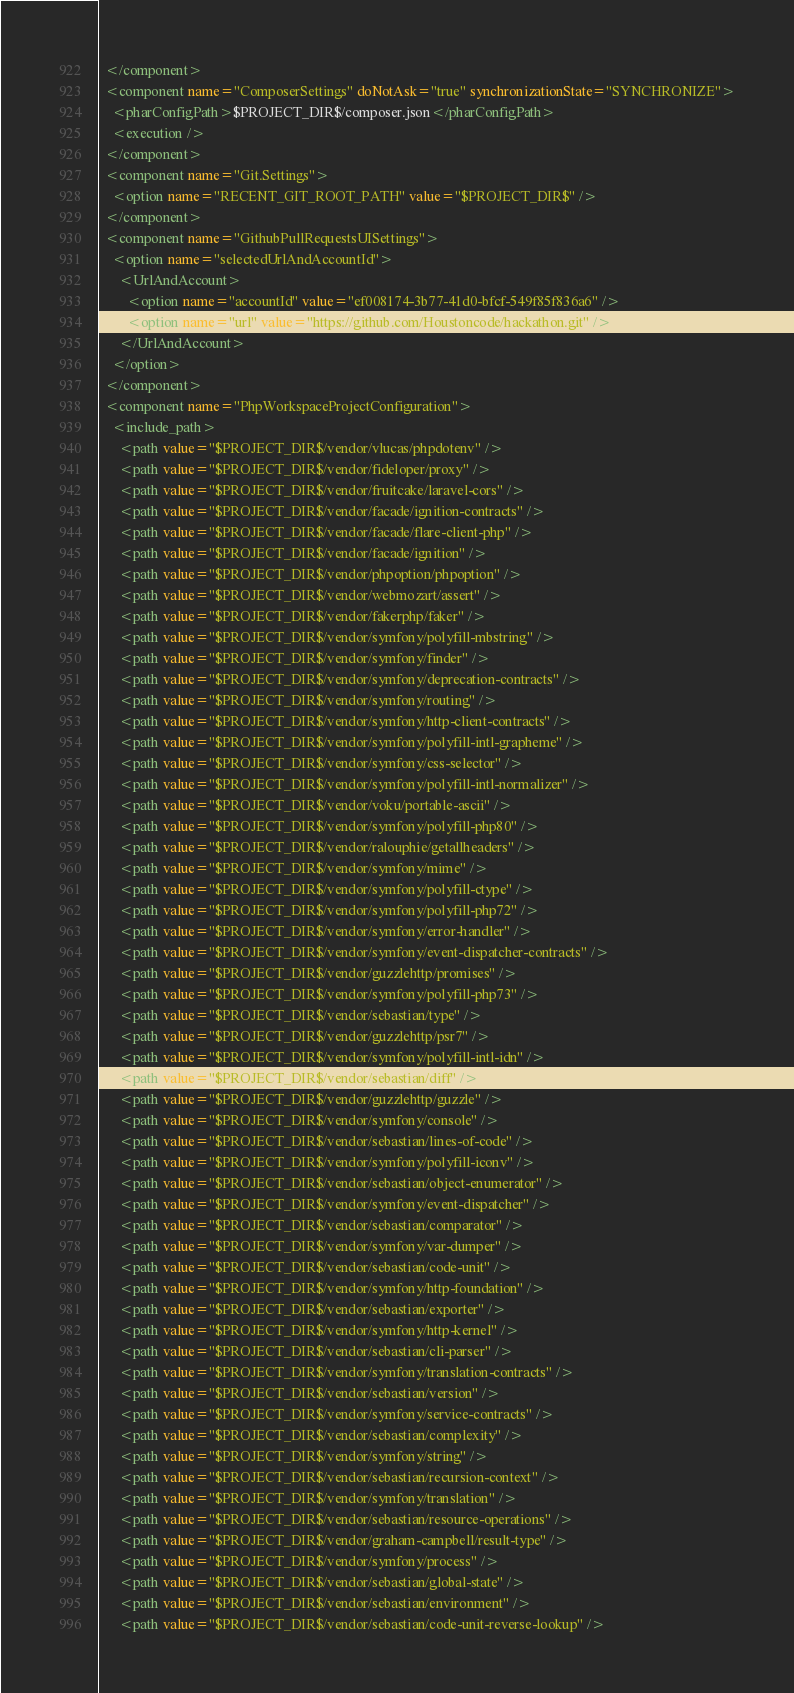Convert code to text. <code><loc_0><loc_0><loc_500><loc_500><_XML_>  </component>
  <component name="ComposerSettings" doNotAsk="true" synchronizationState="SYNCHRONIZE">
    <pharConfigPath>$PROJECT_DIR$/composer.json</pharConfigPath>
    <execution />
  </component>
  <component name="Git.Settings">
    <option name="RECENT_GIT_ROOT_PATH" value="$PROJECT_DIR$" />
  </component>
  <component name="GithubPullRequestsUISettings">
    <option name="selectedUrlAndAccountId">
      <UrlAndAccount>
        <option name="accountId" value="ef008174-3b77-41d0-bfcf-549f85f836a6" />
        <option name="url" value="https://github.com/Houstoncode/hackathon.git" />
      </UrlAndAccount>
    </option>
  </component>
  <component name="PhpWorkspaceProjectConfiguration">
    <include_path>
      <path value="$PROJECT_DIR$/vendor/vlucas/phpdotenv" />
      <path value="$PROJECT_DIR$/vendor/fideloper/proxy" />
      <path value="$PROJECT_DIR$/vendor/fruitcake/laravel-cors" />
      <path value="$PROJECT_DIR$/vendor/facade/ignition-contracts" />
      <path value="$PROJECT_DIR$/vendor/facade/flare-client-php" />
      <path value="$PROJECT_DIR$/vendor/facade/ignition" />
      <path value="$PROJECT_DIR$/vendor/phpoption/phpoption" />
      <path value="$PROJECT_DIR$/vendor/webmozart/assert" />
      <path value="$PROJECT_DIR$/vendor/fakerphp/faker" />
      <path value="$PROJECT_DIR$/vendor/symfony/polyfill-mbstring" />
      <path value="$PROJECT_DIR$/vendor/symfony/finder" />
      <path value="$PROJECT_DIR$/vendor/symfony/deprecation-contracts" />
      <path value="$PROJECT_DIR$/vendor/symfony/routing" />
      <path value="$PROJECT_DIR$/vendor/symfony/http-client-contracts" />
      <path value="$PROJECT_DIR$/vendor/symfony/polyfill-intl-grapheme" />
      <path value="$PROJECT_DIR$/vendor/symfony/css-selector" />
      <path value="$PROJECT_DIR$/vendor/symfony/polyfill-intl-normalizer" />
      <path value="$PROJECT_DIR$/vendor/voku/portable-ascii" />
      <path value="$PROJECT_DIR$/vendor/symfony/polyfill-php80" />
      <path value="$PROJECT_DIR$/vendor/ralouphie/getallheaders" />
      <path value="$PROJECT_DIR$/vendor/symfony/mime" />
      <path value="$PROJECT_DIR$/vendor/symfony/polyfill-ctype" />
      <path value="$PROJECT_DIR$/vendor/symfony/polyfill-php72" />
      <path value="$PROJECT_DIR$/vendor/symfony/error-handler" />
      <path value="$PROJECT_DIR$/vendor/symfony/event-dispatcher-contracts" />
      <path value="$PROJECT_DIR$/vendor/guzzlehttp/promises" />
      <path value="$PROJECT_DIR$/vendor/symfony/polyfill-php73" />
      <path value="$PROJECT_DIR$/vendor/sebastian/type" />
      <path value="$PROJECT_DIR$/vendor/guzzlehttp/psr7" />
      <path value="$PROJECT_DIR$/vendor/symfony/polyfill-intl-idn" />
      <path value="$PROJECT_DIR$/vendor/sebastian/diff" />
      <path value="$PROJECT_DIR$/vendor/guzzlehttp/guzzle" />
      <path value="$PROJECT_DIR$/vendor/symfony/console" />
      <path value="$PROJECT_DIR$/vendor/sebastian/lines-of-code" />
      <path value="$PROJECT_DIR$/vendor/symfony/polyfill-iconv" />
      <path value="$PROJECT_DIR$/vendor/sebastian/object-enumerator" />
      <path value="$PROJECT_DIR$/vendor/symfony/event-dispatcher" />
      <path value="$PROJECT_DIR$/vendor/sebastian/comparator" />
      <path value="$PROJECT_DIR$/vendor/symfony/var-dumper" />
      <path value="$PROJECT_DIR$/vendor/sebastian/code-unit" />
      <path value="$PROJECT_DIR$/vendor/symfony/http-foundation" />
      <path value="$PROJECT_DIR$/vendor/sebastian/exporter" />
      <path value="$PROJECT_DIR$/vendor/symfony/http-kernel" />
      <path value="$PROJECT_DIR$/vendor/sebastian/cli-parser" />
      <path value="$PROJECT_DIR$/vendor/symfony/translation-contracts" />
      <path value="$PROJECT_DIR$/vendor/sebastian/version" />
      <path value="$PROJECT_DIR$/vendor/symfony/service-contracts" />
      <path value="$PROJECT_DIR$/vendor/sebastian/complexity" />
      <path value="$PROJECT_DIR$/vendor/symfony/string" />
      <path value="$PROJECT_DIR$/vendor/sebastian/recursion-context" />
      <path value="$PROJECT_DIR$/vendor/symfony/translation" />
      <path value="$PROJECT_DIR$/vendor/sebastian/resource-operations" />
      <path value="$PROJECT_DIR$/vendor/graham-campbell/result-type" />
      <path value="$PROJECT_DIR$/vendor/symfony/process" />
      <path value="$PROJECT_DIR$/vendor/sebastian/global-state" />
      <path value="$PROJECT_DIR$/vendor/sebastian/environment" />
      <path value="$PROJECT_DIR$/vendor/sebastian/code-unit-reverse-lookup" /></code> 